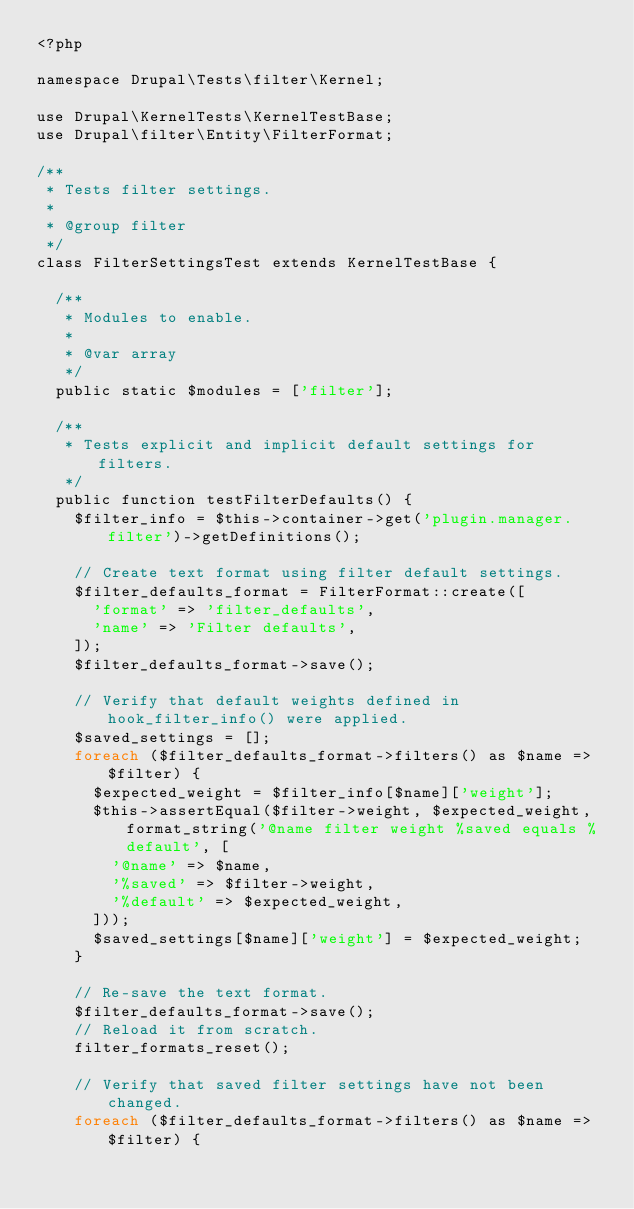<code> <loc_0><loc_0><loc_500><loc_500><_PHP_><?php

namespace Drupal\Tests\filter\Kernel;

use Drupal\KernelTests\KernelTestBase;
use Drupal\filter\Entity\FilterFormat;

/**
 * Tests filter settings.
 *
 * @group filter
 */
class FilterSettingsTest extends KernelTestBase {

  /**
   * Modules to enable.
   *
   * @var array
   */
  public static $modules = ['filter'];

  /**
   * Tests explicit and implicit default settings for filters.
   */
  public function testFilterDefaults() {
    $filter_info = $this->container->get('plugin.manager.filter')->getDefinitions();

    // Create text format using filter default settings.
    $filter_defaults_format = FilterFormat::create([
      'format' => 'filter_defaults',
      'name' => 'Filter defaults',
    ]);
    $filter_defaults_format->save();

    // Verify that default weights defined in hook_filter_info() were applied.
    $saved_settings = [];
    foreach ($filter_defaults_format->filters() as $name => $filter) {
      $expected_weight = $filter_info[$name]['weight'];
      $this->assertEqual($filter->weight, $expected_weight, format_string('@name filter weight %saved equals %default', [
        '@name' => $name,
        '%saved' => $filter->weight,
        '%default' => $expected_weight,
      ]));
      $saved_settings[$name]['weight'] = $expected_weight;
    }

    // Re-save the text format.
    $filter_defaults_format->save();
    // Reload it from scratch.
    filter_formats_reset();

    // Verify that saved filter settings have not been changed.
    foreach ($filter_defaults_format->filters() as $name => $filter) {</code> 